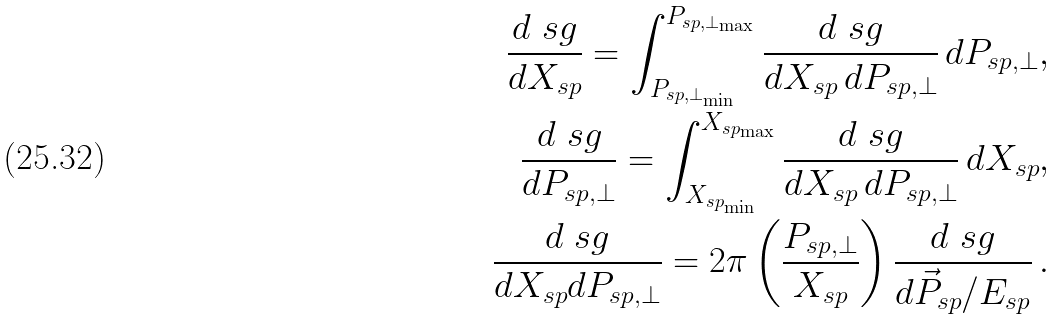<formula> <loc_0><loc_0><loc_500><loc_500>\frac { d \ s g } { d X _ { s p } } = \int _ { P _ { s p , \bot _ { \min } } } ^ { P _ { s p , \bot _ { \max } } } \frac { d \ s g } { d X _ { s p } \, d P _ { s p , \bot } } \, d P _ { s p , \bot } , \\ \frac { d \ s g } { d P _ { s p , \bot } } = \int _ { X _ { s p _ { \min } } } ^ { X _ { s p _ { \max } } } \frac { d \ s g } { d X _ { s p } \, d P _ { s p , \bot } } \, d X _ { s p } , \\ \frac { d \ s g } { d X _ { s p } d P _ { s p , \bot } } = 2 \pi \left ( \frac { P _ { s p , \bot } } { X _ { s p } } \right ) \frac { d \ s g } { d \vec { P } _ { s p } / E _ { s p } } \, .</formula> 